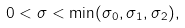Convert formula to latex. <formula><loc_0><loc_0><loc_500><loc_500>0 < \sigma < \min ( \sigma _ { 0 } , \sigma _ { 1 } , \sigma _ { 2 } ) ,</formula> 